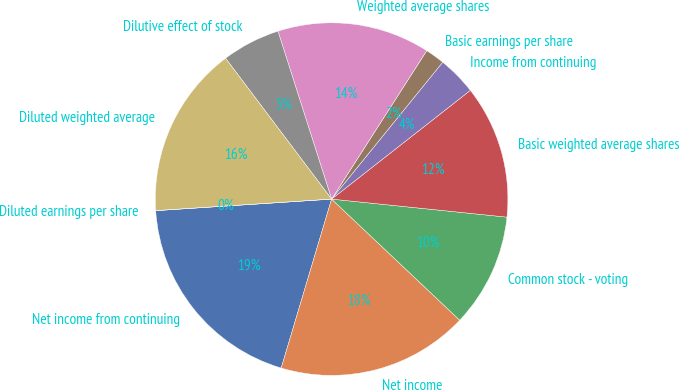Convert chart. <chart><loc_0><loc_0><loc_500><loc_500><pie_chart><fcel>Net income from continuing<fcel>Net income<fcel>Common stock - voting<fcel>Basic weighted average shares<fcel>Income from continuing<fcel>Basic earnings per share<fcel>Weighted average shares<fcel>Dilutive effect of stock<fcel>Diluted weighted average<fcel>Diluted earnings per share<nl><fcel>19.34%<fcel>17.56%<fcel>10.42%<fcel>12.21%<fcel>3.57%<fcel>1.78%<fcel>13.99%<fcel>5.35%<fcel>15.77%<fcel>0.0%<nl></chart> 